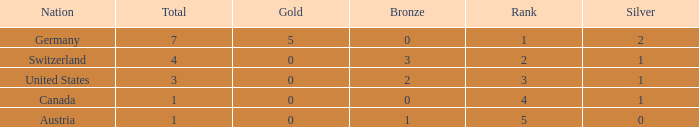What is the full amount of Total for Austria when the number of gold is less than 0? None. 